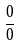<formula> <loc_0><loc_0><loc_500><loc_500>\frac { 0 } { 0 }</formula> 